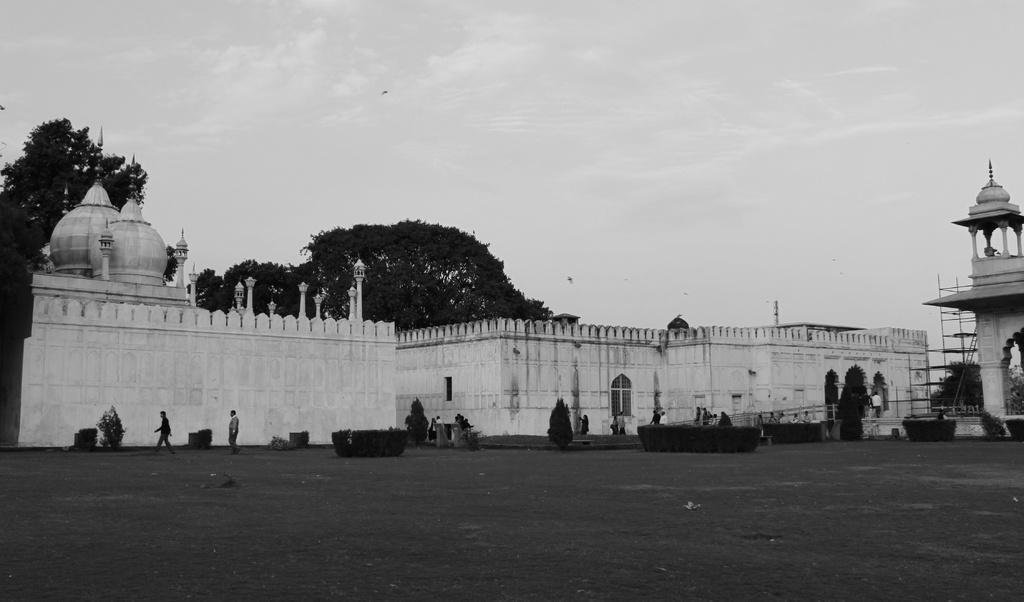How would you summarize this image in a sentence or two? This picture is in black and white. In the center there are old buildings with poles. Towards the right there is a minar. At the bottom there is grass. Before the buildings there are people. On the top there is a sky and trees. 